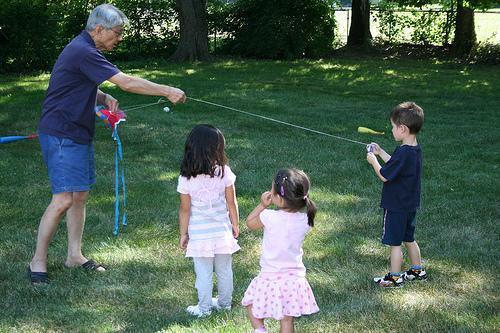How many people have their hair in a pony tail?
Give a very brief answer. 1. 